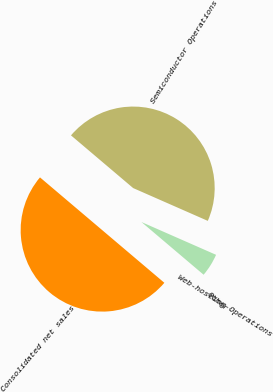Convert chart to OTSL. <chart><loc_0><loc_0><loc_500><loc_500><pie_chart><fcel>Semiconductor Operations<fcel>Web-hosting Operations<fcel>Other<fcel>Consolidated net sales<nl><fcel>45.4%<fcel>4.6%<fcel>0.0%<fcel>50.0%<nl></chart> 